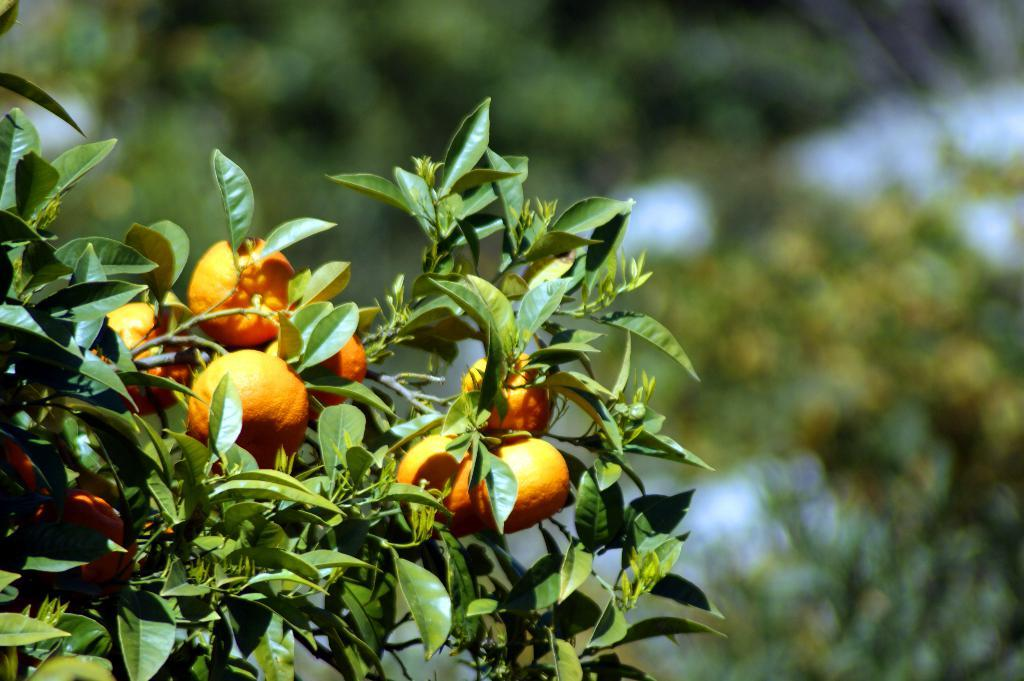What type of fruit is in the foreground of the image? There are oranges in the foreground of the image. Where are the oranges located? The oranges are on a tree. Can you describe the background of the image? The background of the image is blurred. Who is driving the car in the image? There is no car or person driving in the image; it features oranges on a tree with a blurred background. 